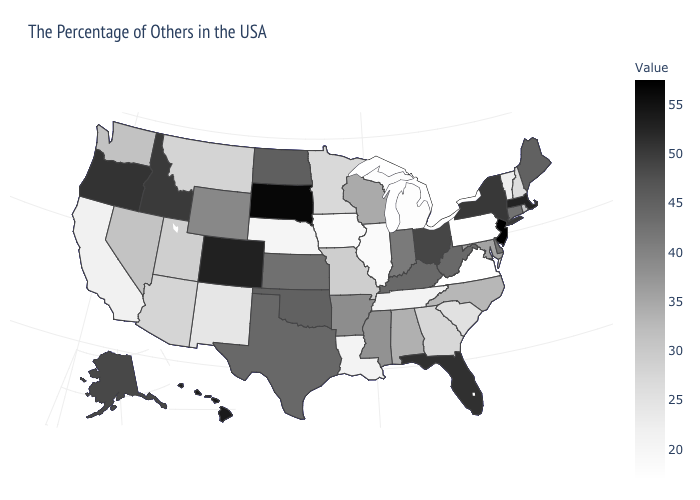Among the states that border Maryland , which have the lowest value?
Give a very brief answer. Pennsylvania. Does Minnesota have the lowest value in the MidWest?
Concise answer only. No. Which states have the lowest value in the USA?
Give a very brief answer. Pennsylvania. Does Pennsylvania have the lowest value in the USA?
Concise answer only. Yes. Which states have the lowest value in the USA?
Keep it brief. Pennsylvania. Does Maine have the highest value in the Northeast?
Give a very brief answer. No. Among the states that border Virginia , which have the lowest value?
Answer briefly. Tennessee. Does the map have missing data?
Quick response, please. No. 